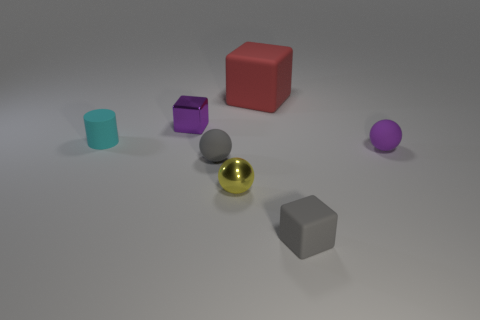What shape is the thing that is the same color as the small metallic block?
Provide a succinct answer. Sphere. There is a cyan cylinder that is the same material as the red block; what is its size?
Your answer should be very brief. Small. Does the large object have the same color as the rubber cylinder?
Ensure brevity in your answer.  No. There is another gray object that is the same shape as the large rubber object; what is its material?
Your response must be concise. Rubber. What is the color of the small sphere that is both to the left of the small gray rubber cube and to the right of the small gray matte sphere?
Keep it short and to the point. Yellow. Is there anything else that is the same color as the tiny cylinder?
Offer a terse response. No. What number of things are either objects that are behind the yellow sphere or small balls left of the yellow metal thing?
Your response must be concise. 5. There is a matte object that is both on the left side of the tiny yellow thing and to the right of the tiny cyan cylinder; what shape is it?
Your answer should be compact. Sphere. There is a cube behind the tiny shiny block; what number of tiny rubber cubes are to the right of it?
Your answer should be compact. 1. Is there anything else that is the same material as the gray block?
Your answer should be very brief. Yes. 